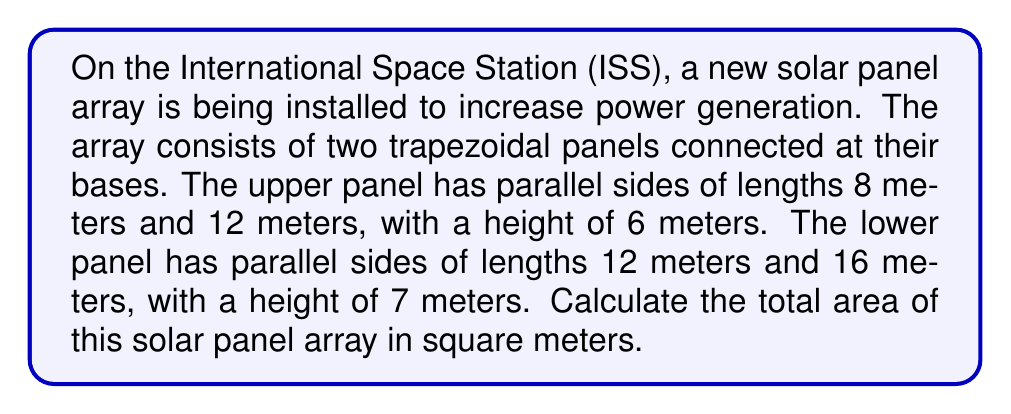Can you answer this question? Let's approach this step-by-step:

1) The area of a trapezoid is given by the formula:
   $$A = \frac{1}{2}(b_1 + b_2)h$$
   where $b_1$ and $b_2$ are the lengths of the parallel sides and $h$ is the height.

2) For the upper panel:
   $b_1 = 8$ m, $b_2 = 12$ m, $h = 6$ m
   $$A_1 = \frac{1}{2}(8 + 12) \cdot 6 = \frac{1}{2}(20) \cdot 6 = 10 \cdot 6 = 60$$ sq m

3) For the lower panel:
   $b_1 = 12$ m, $b_2 = 16$ m, $h = 7$ m
   $$A_2 = \frac{1}{2}(12 + 16) \cdot 7 = \frac{1}{2}(28) \cdot 7 = 14 \cdot 7 = 98$$ sq m

4) The total area is the sum of these two areas:
   $$A_{total} = A_1 + A_2 = 60 + 98 = 158$$ sq m

[asy]
unitsize(4mm);
path p1 = (0,0)--(16,0)--(12,7)--(4,7)--cycle;
path p2 = (4,7)--(12,7)--(8,13)--(2,13)--cycle;
fill(p1,lightgrey);
fill(p2,lightgrey);
draw(p1);
draw(p2);
label("16m", (8,0), S);
label("12m", (8,7), S);
label("8m", (5,13), N);
label("7m", (16,3.5), E);
label("6m", (12,10), E);
[/asy]
Answer: 158 sq m 